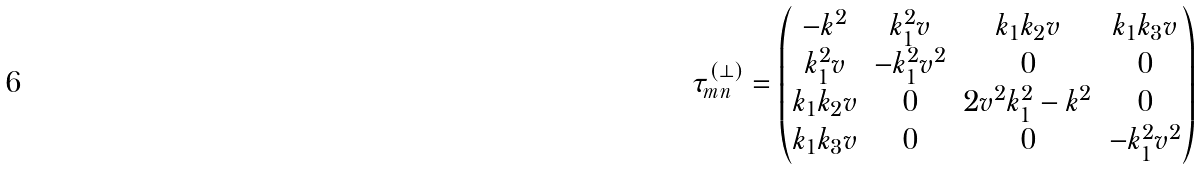<formula> <loc_0><loc_0><loc_500><loc_500>\tau ^ { ( \bot ) } _ { m n } = \begin{pmatrix} - k ^ { 2 } & k _ { 1 } ^ { 2 } v & k _ { 1 } k _ { 2 } v & k _ { 1 } k _ { 3 } v \\ k _ { 1 } ^ { 2 } v & - k _ { 1 } ^ { 2 } v ^ { 2 } & 0 & 0 \\ k _ { 1 } k _ { 2 } v & 0 & 2 v ^ { 2 } k _ { 1 } ^ { 2 } - k ^ { 2 } & 0 \\ k _ { 1 } k _ { 3 } v & 0 & 0 & - k _ { 1 } ^ { 2 } v ^ { 2 } \end{pmatrix}</formula> 